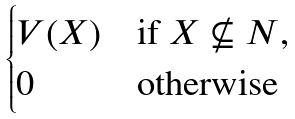Convert formula to latex. <formula><loc_0><loc_0><loc_500><loc_500>\begin{cases} V ( X ) & \text {if $X \not \subseteq N$} , \\ 0 & \text {otherwise} \end{cases}</formula> 